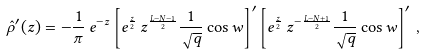<formula> <loc_0><loc_0><loc_500><loc_500>\hat { \rho } ^ { \prime } ( z ) = - \frac { 1 } { \pi } \, e ^ { - z } \left [ e ^ { \frac { z } { 2 } } \, z ^ { \frac { L - N - 1 } { 2 } } \frac { 1 } { \sqrt { q } } \cos w \right ] ^ { \prime } \left [ e ^ { \frac { z } { 2 } } \, z ^ { - \frac { L - N + 1 } { 2 } } \frac { 1 } { \sqrt { q } } \cos w \right ] ^ { \prime } \, ,</formula> 